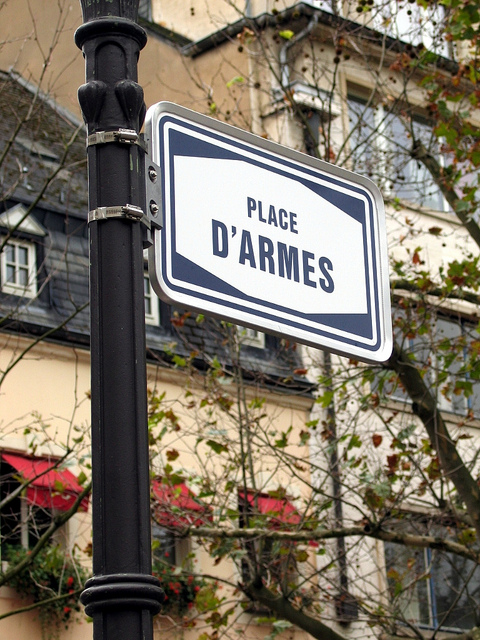Read all the text in this image. D'ARMES PLACE 